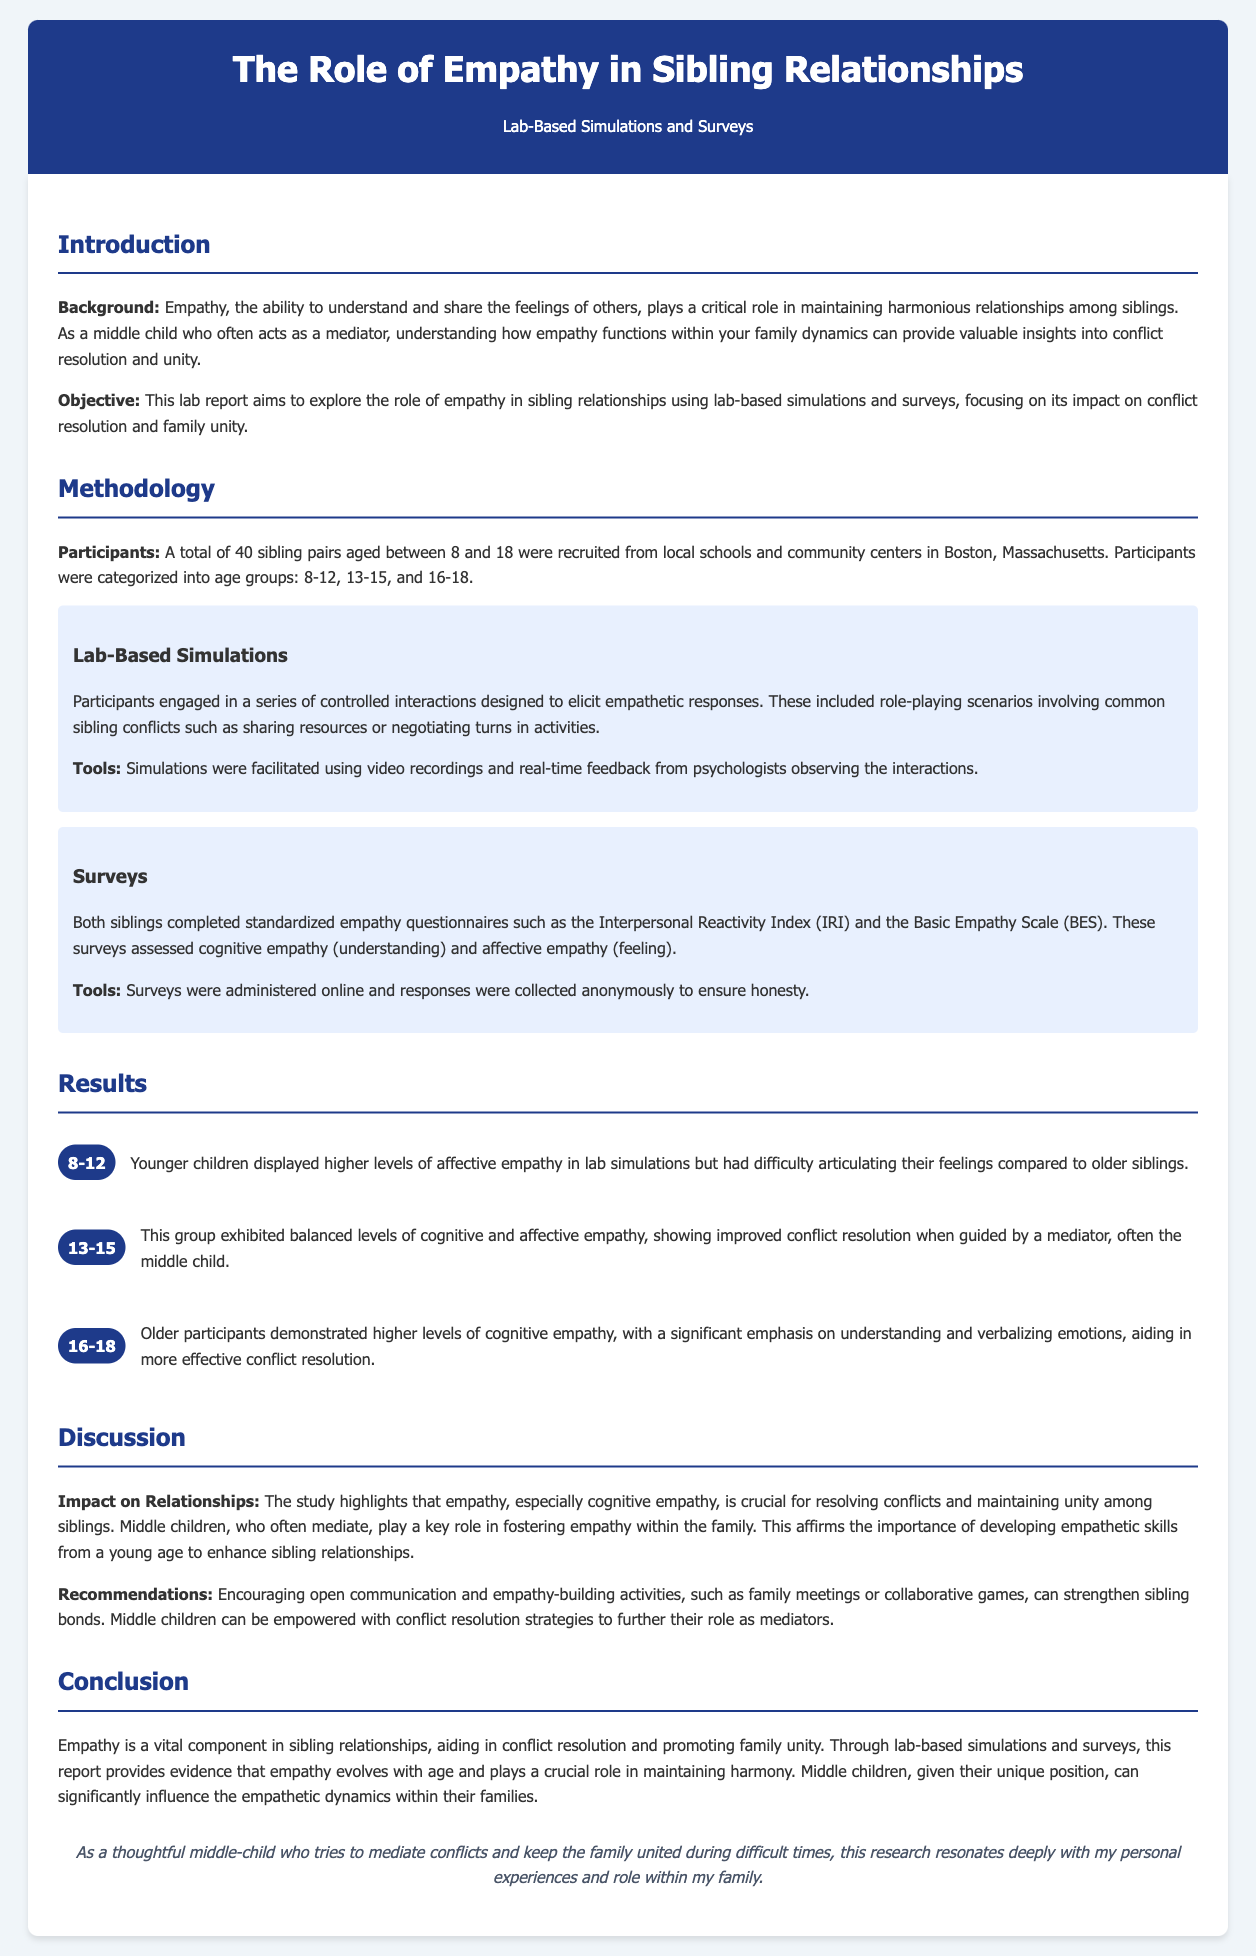what is the total number of sibling pairs involved in the study? The total number of sibling pairs is specifically mentioned in the document as being recruited for the study.
Answer: 40 what age range did the participants fall into? The document specifies the age range of participants who were involved in the study.
Answer: 8 to 18 which empathy questionnaire was used in the study? The study utilized specific standardized empathy questionnaires which are named in the document.
Answer: Interpersonal Reactivity Index what was a key finding for the 8-12 age group? The document provides insights into the empathetic responses displayed by the younger children during the lab simulations.
Answer: Higher levels of affective empathy how did the 13-15 age group respond in terms of empathy? The level of empathy exhibited by this age group is described in the results section.
Answer: Balanced levels who typically plays the role of mediator in sibling conflicts according to the study? The document notes which sibling often takes on the mediator role during conflicts.
Answer: Middle child what conclusion is drawn about the role of empathy in sibling relationships? The report summarizes the essential role of empathy based on the results of the study.
Answer: Vital component what recommendations are made to strengthen sibling bonds? The document suggests actionable strategies to enhance familial relationships based on findings from the study.
Answer: Open communication and empathy-building activities 